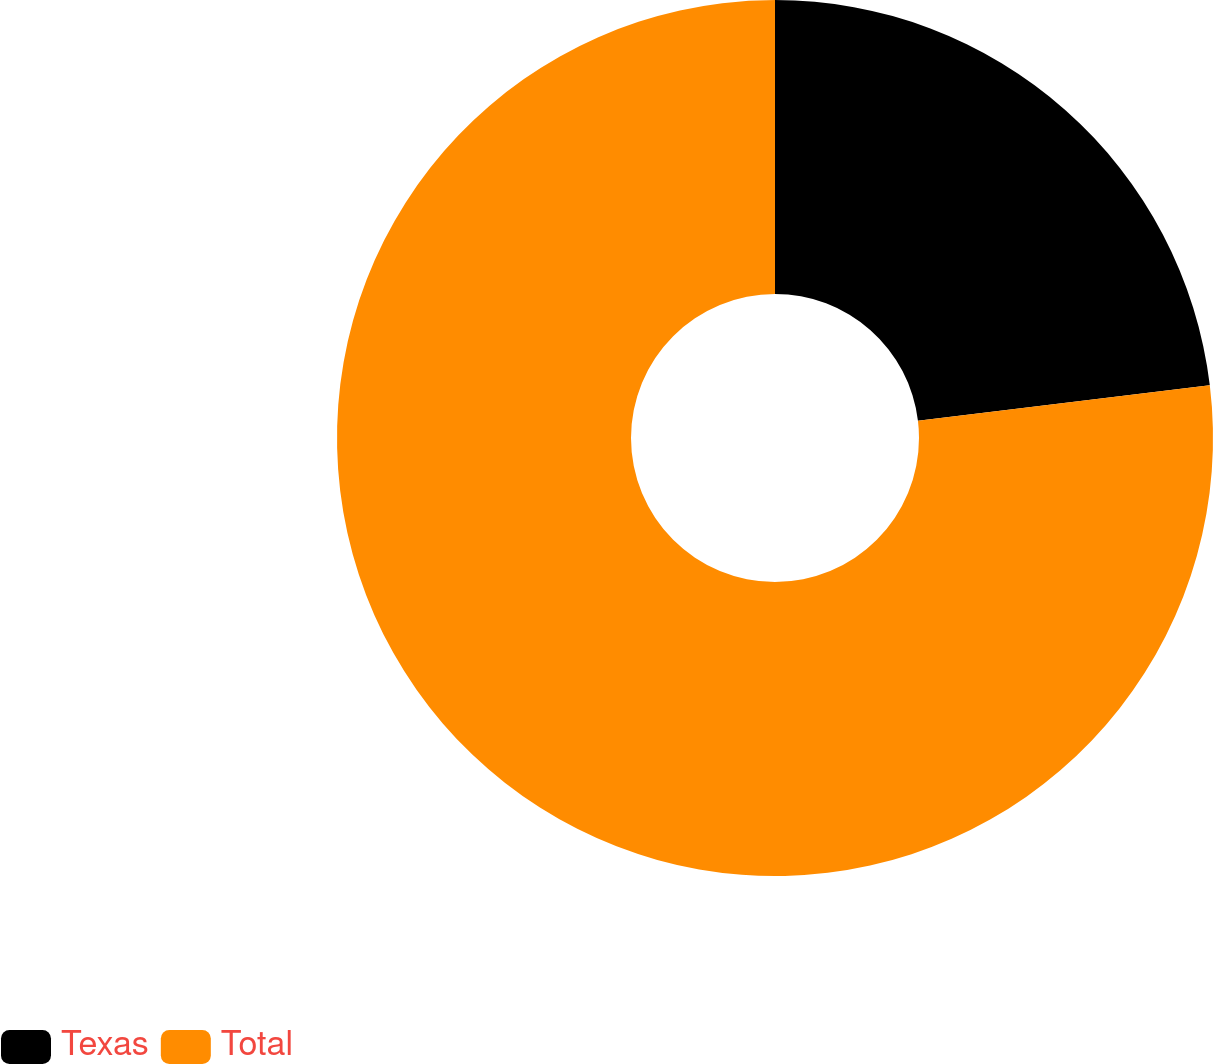<chart> <loc_0><loc_0><loc_500><loc_500><pie_chart><fcel>Texas<fcel>Total<nl><fcel>23.08%<fcel>76.92%<nl></chart> 